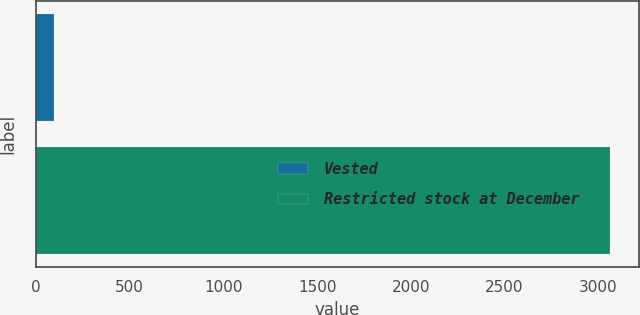Convert chart to OTSL. <chart><loc_0><loc_0><loc_500><loc_500><bar_chart><fcel>Vested<fcel>Restricted stock at December<nl><fcel>97<fcel>3063<nl></chart> 